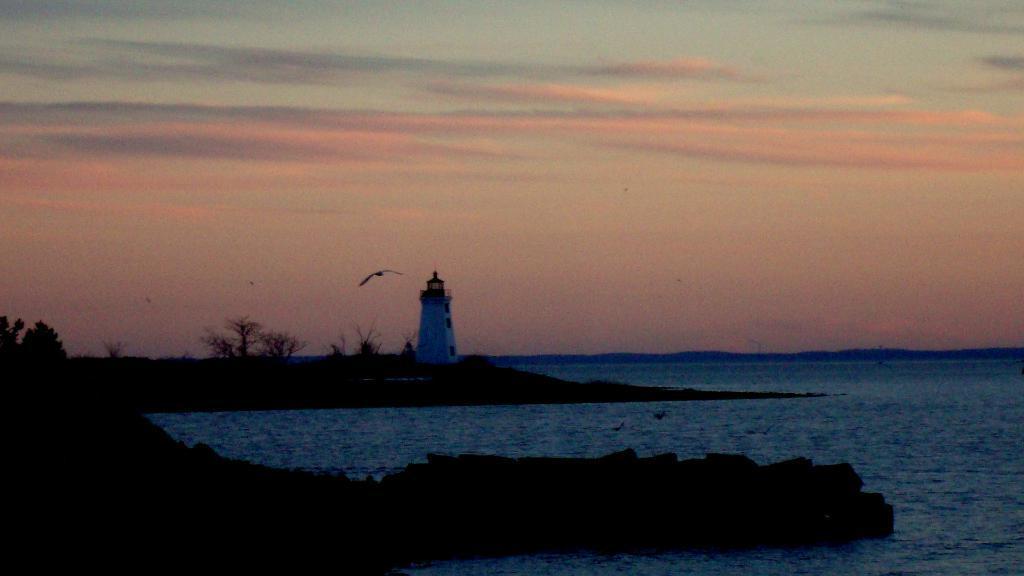How would you summarize this image in a sentence or two? In this image we can see water. And there is a lighthouse. And we can see trees. And there is a bird flying. In the background there is sky with clouds. 